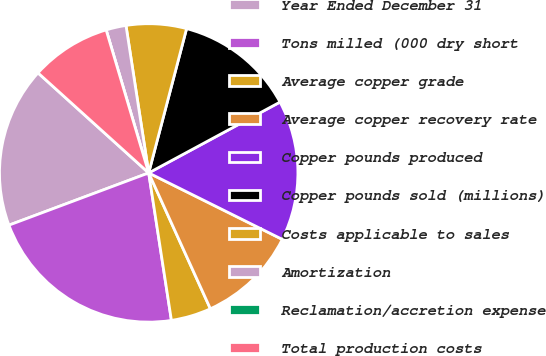Convert chart to OTSL. <chart><loc_0><loc_0><loc_500><loc_500><pie_chart><fcel>Year Ended December 31<fcel>Tons milled (000 dry short<fcel>Average copper grade<fcel>Average copper recovery rate<fcel>Copper pounds produced<fcel>Copper pounds sold (millions)<fcel>Costs applicable to sales<fcel>Amortization<fcel>Reclamation/accretion expense<fcel>Total production costs<nl><fcel>17.39%<fcel>21.74%<fcel>4.35%<fcel>10.87%<fcel>15.22%<fcel>13.04%<fcel>6.52%<fcel>2.17%<fcel>0.0%<fcel>8.7%<nl></chart> 